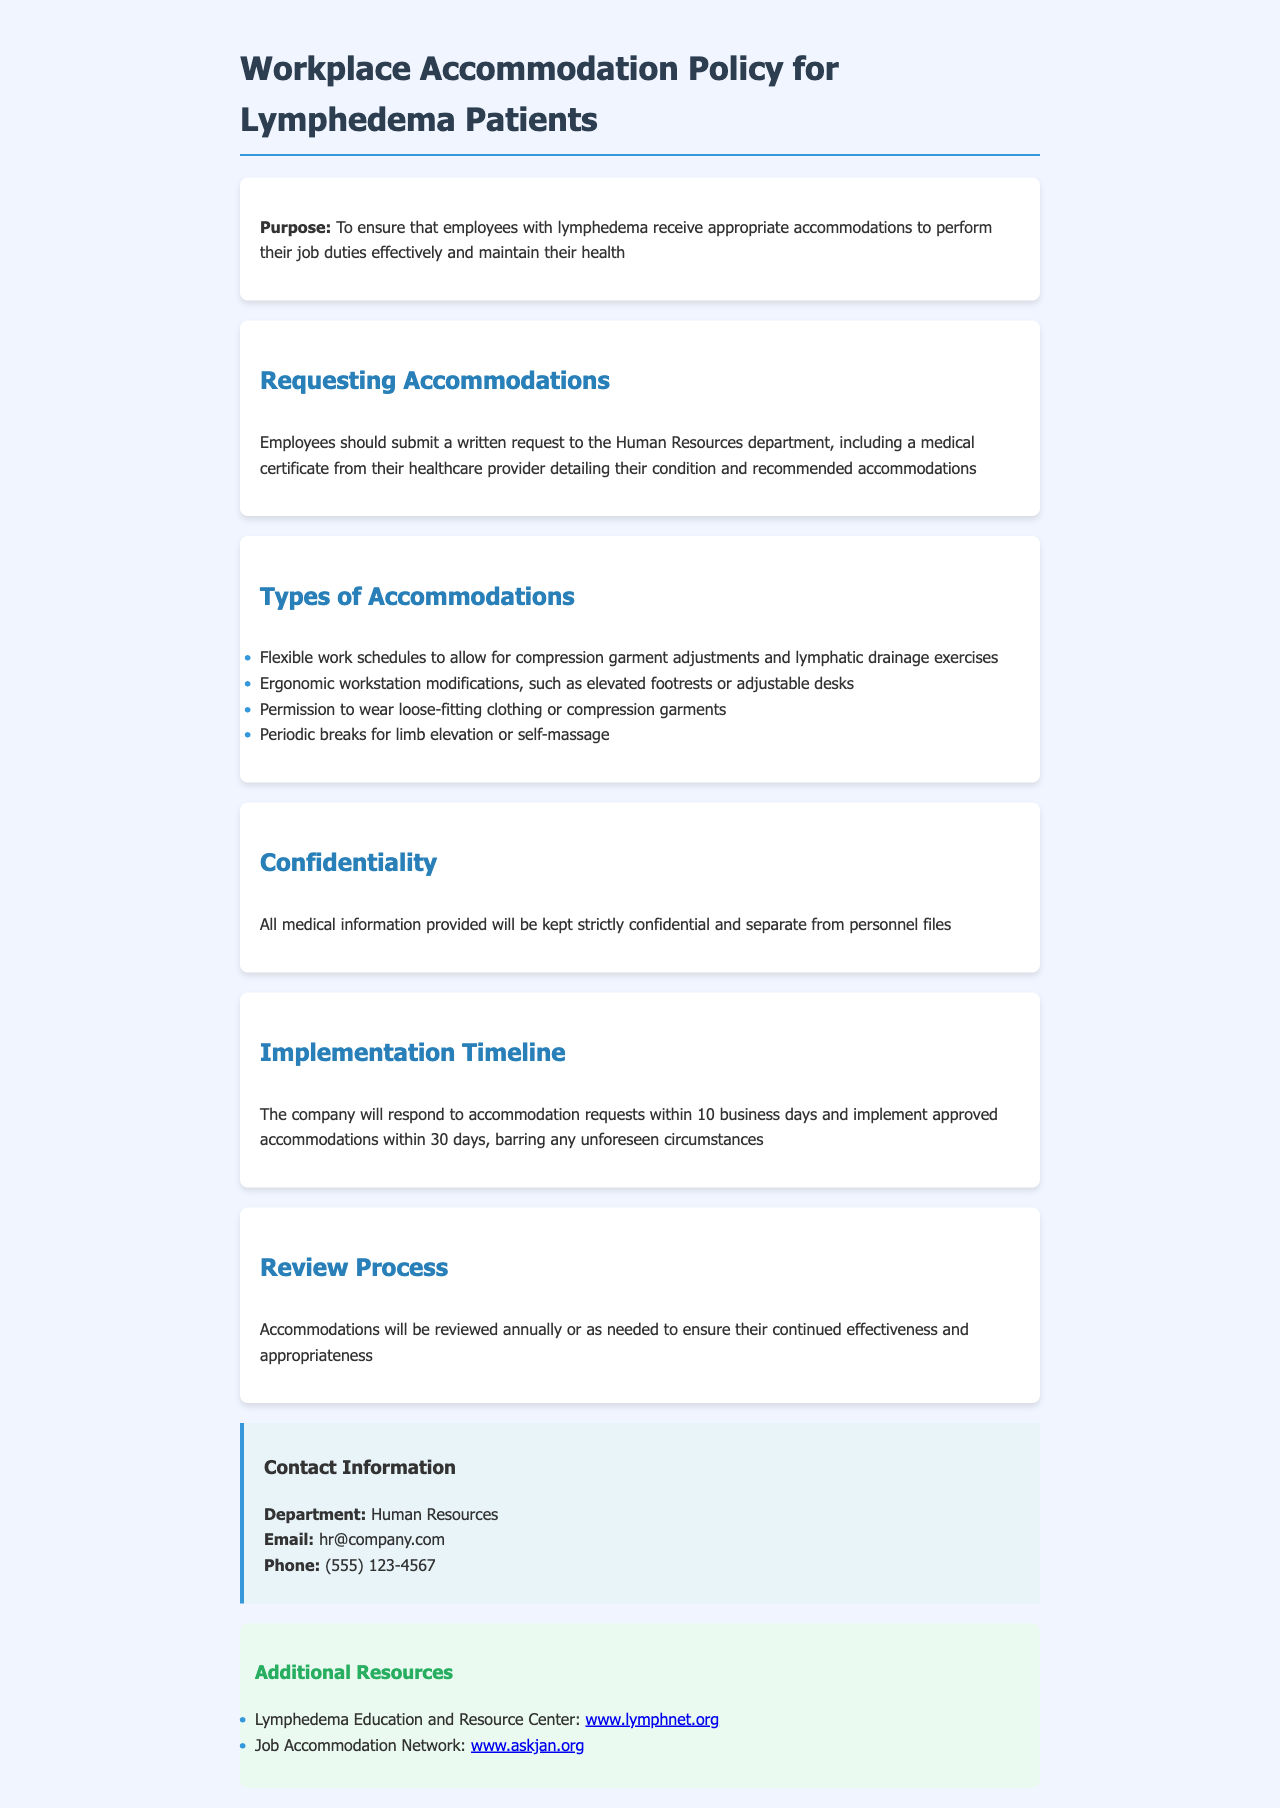What is the purpose of the policy? The purpose is to ensure that employees with lymphedema receive appropriate accommodations to perform their job duties effectively and maintain their health.
Answer: To ensure that employees with lymphedema receive appropriate accommodations What should an employee include in the accommodation request? Employees should submit a written request including a medical certificate detailing their condition and recommended accommodations.
Answer: A medical certificate What is the timeframe for the company to respond to accommodation requests? The company will respond to accommodation requests within 10 business days.
Answer: 10 business days What types of ergonomic modifications are mentioned? Ergonomic workstation modifications include elevated footrests or adjustable desks.
Answer: Elevated footrests or adjustable desks How often will accommodations be reviewed? Accommodations will be reviewed annually or as needed.
Answer: Annually What is the contact email for Human Resources? The contact email for Human Resources is provided in the document.
Answer: hr@company.com What additional resources are provided in the document? Additional resources include links to the Lymphedema Education and Resource Center and Job Accommodation Network.
Answer: Lymphedema Education and Resource Center and Job Accommodation Network What is the confidentiality policy regarding medical information? All medical information provided will be kept strictly confidential and separate from personnel files.
Answer: Strictly confidential What type of clothing is permitted for employees with lymphedema? Employees may wear loose-fitting clothing or compression garments.
Answer: Loose-fitting clothing or compression garments 